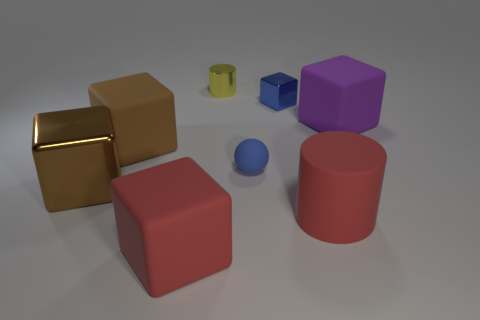There is a red cube that is the same size as the rubber cylinder; what material is it?
Your answer should be very brief. Rubber. What number of objects are cylinders that are left of the tiny blue metal object or big brown objects?
Ensure brevity in your answer.  3. Are there any blue rubber balls?
Keep it short and to the point. Yes. There is a cylinder that is on the right side of the small yellow shiny object; what is it made of?
Provide a succinct answer. Rubber. There is a tiny thing that is the same color as the rubber sphere; what material is it?
Offer a terse response. Metal. How many large things are either rubber blocks or blue spheres?
Make the answer very short. 3. The large shiny thing is what color?
Your answer should be compact. Brown. Is there a purple rubber thing that is on the right side of the cylinder that is in front of the tiny cube?
Your answer should be very brief. Yes. Is the number of cylinders that are on the right side of the yellow metallic thing less than the number of large blue balls?
Provide a short and direct response. No. Does the purple cube that is in front of the yellow metallic cylinder have the same material as the big red cylinder?
Offer a terse response. Yes. 